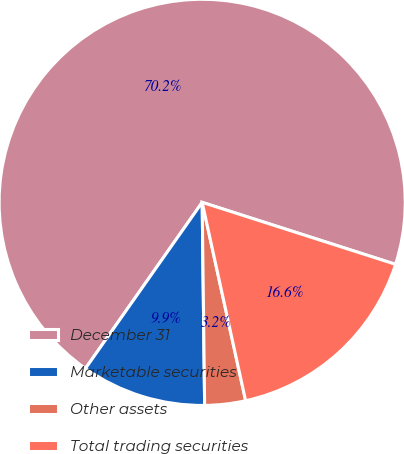Convert chart. <chart><loc_0><loc_0><loc_500><loc_500><pie_chart><fcel>December 31<fcel>Marketable securities<fcel>Other assets<fcel>Total trading securities<nl><fcel>70.19%<fcel>9.94%<fcel>3.24%<fcel>16.63%<nl></chart> 